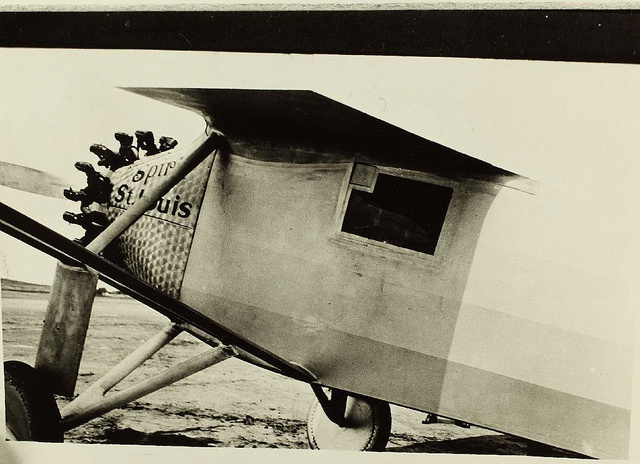Describe the objects in this image and their specific colors. I can see a airplane in beige, black, tan, and gray tones in this image. 